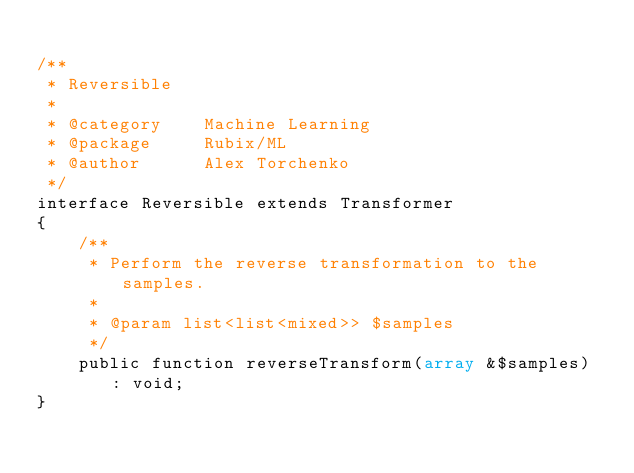<code> <loc_0><loc_0><loc_500><loc_500><_PHP_>
/**
 * Reversible
 *
 * @category    Machine Learning
 * @package     Rubix/ML
 * @author      Alex Torchenko
 */
interface Reversible extends Transformer
{
    /**
     * Perform the reverse transformation to the samples.
     *
     * @param list<list<mixed>> $samples
     */
    public function reverseTransform(array &$samples) : void;
}
</code> 